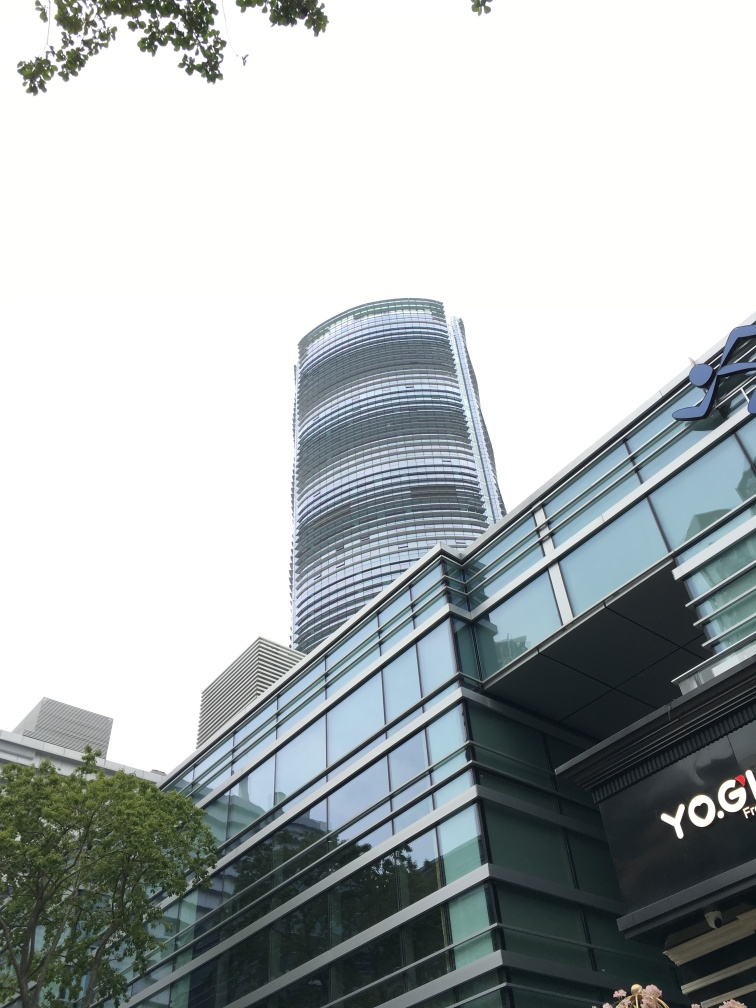Could you tell me about the weather conditions depicted in the photograph? The photograph shows an overcast sky, with no direct sunlight visible. The muted lighting and the absence of shadows suggest an overcast or cloudy day. The overall ambiance is one without harsh contrasts, which further emphasizes the subtle variations in light across the building surfaces. 